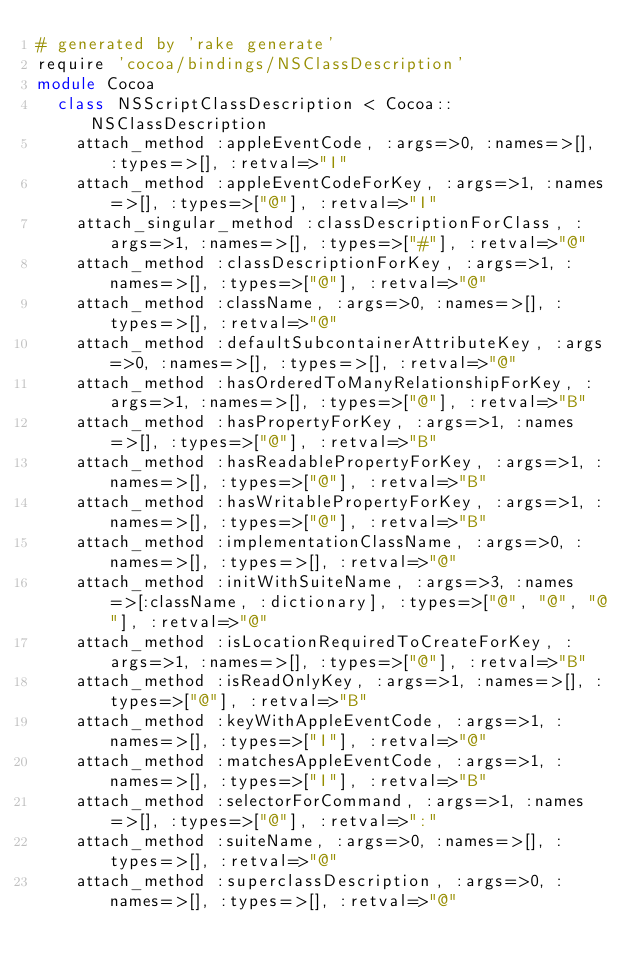Convert code to text. <code><loc_0><loc_0><loc_500><loc_500><_Ruby_># generated by 'rake generate'
require 'cocoa/bindings/NSClassDescription'
module Cocoa
  class NSScriptClassDescription < Cocoa::NSClassDescription
    attach_method :appleEventCode, :args=>0, :names=>[], :types=>[], :retval=>"I"
    attach_method :appleEventCodeForKey, :args=>1, :names=>[], :types=>["@"], :retval=>"I"
    attach_singular_method :classDescriptionForClass, :args=>1, :names=>[], :types=>["#"], :retval=>"@"
    attach_method :classDescriptionForKey, :args=>1, :names=>[], :types=>["@"], :retval=>"@"
    attach_method :className, :args=>0, :names=>[], :types=>[], :retval=>"@"
    attach_method :defaultSubcontainerAttributeKey, :args=>0, :names=>[], :types=>[], :retval=>"@"
    attach_method :hasOrderedToManyRelationshipForKey, :args=>1, :names=>[], :types=>["@"], :retval=>"B"
    attach_method :hasPropertyForKey, :args=>1, :names=>[], :types=>["@"], :retval=>"B"
    attach_method :hasReadablePropertyForKey, :args=>1, :names=>[], :types=>["@"], :retval=>"B"
    attach_method :hasWritablePropertyForKey, :args=>1, :names=>[], :types=>["@"], :retval=>"B"
    attach_method :implementationClassName, :args=>0, :names=>[], :types=>[], :retval=>"@"
    attach_method :initWithSuiteName, :args=>3, :names=>[:className, :dictionary], :types=>["@", "@", "@"], :retval=>"@"
    attach_method :isLocationRequiredToCreateForKey, :args=>1, :names=>[], :types=>["@"], :retval=>"B"
    attach_method :isReadOnlyKey, :args=>1, :names=>[], :types=>["@"], :retval=>"B"
    attach_method :keyWithAppleEventCode, :args=>1, :names=>[], :types=>["I"], :retval=>"@"
    attach_method :matchesAppleEventCode, :args=>1, :names=>[], :types=>["I"], :retval=>"B"
    attach_method :selectorForCommand, :args=>1, :names=>[], :types=>["@"], :retval=>":"
    attach_method :suiteName, :args=>0, :names=>[], :types=>[], :retval=>"@"
    attach_method :superclassDescription, :args=>0, :names=>[], :types=>[], :retval=>"@"</code> 